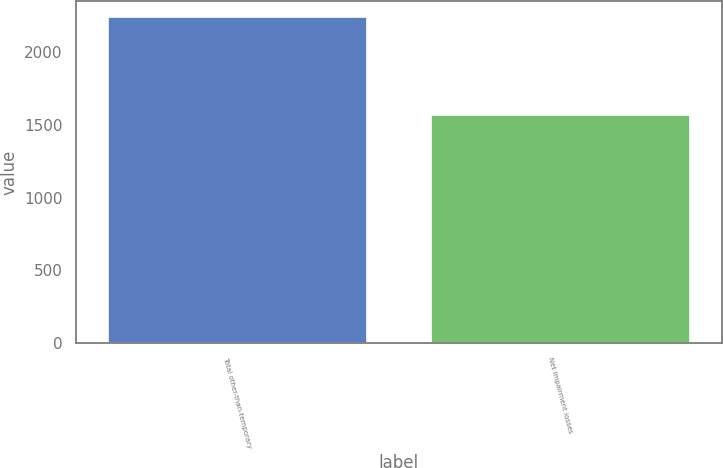Convert chart to OTSL. <chart><loc_0><loc_0><loc_500><loc_500><bar_chart><fcel>Total other-than-temporary<fcel>Net impairment losses<nl><fcel>2240<fcel>1568<nl></chart> 